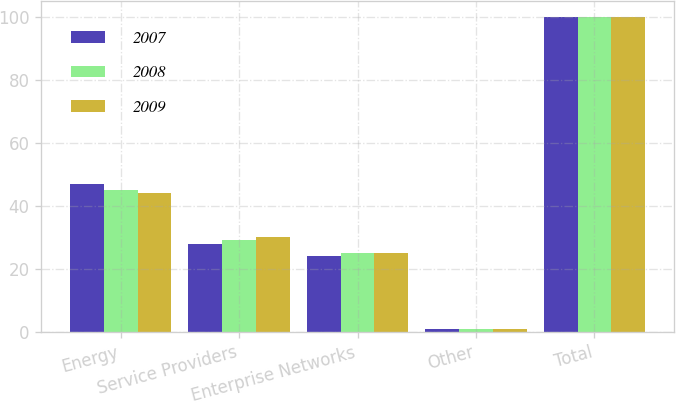Convert chart to OTSL. <chart><loc_0><loc_0><loc_500><loc_500><stacked_bar_chart><ecel><fcel>Energy<fcel>Service Providers<fcel>Enterprise Networks<fcel>Other<fcel>Total<nl><fcel>2007<fcel>47<fcel>28<fcel>24<fcel>1<fcel>100<nl><fcel>2008<fcel>45<fcel>29<fcel>25<fcel>1<fcel>100<nl><fcel>2009<fcel>44<fcel>30<fcel>25<fcel>1<fcel>100<nl></chart> 